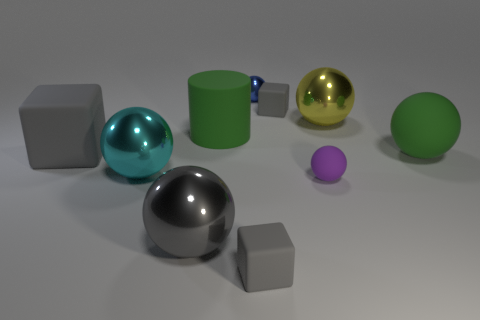How many gray cubes must be subtracted to get 1 gray cubes? 2 Subtract all yellow balls. How many balls are left? 5 Subtract all tiny rubber spheres. How many spheres are left? 5 Subtract 1 blocks. How many blocks are left? 2 Subtract all brown spheres. Subtract all yellow cylinders. How many spheres are left? 6 Subtract all cylinders. How many objects are left? 9 Subtract 1 purple balls. How many objects are left? 9 Subtract all large shiny balls. Subtract all big green cylinders. How many objects are left? 6 Add 7 big gray rubber objects. How many big gray rubber objects are left? 8 Add 4 large yellow shiny balls. How many large yellow shiny balls exist? 5 